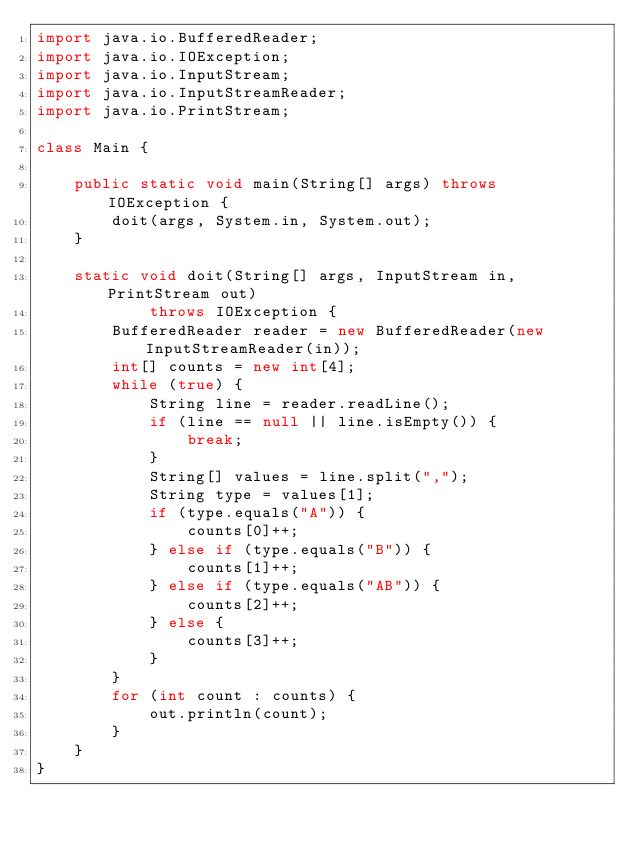Convert code to text. <code><loc_0><loc_0><loc_500><loc_500><_Java_>import java.io.BufferedReader;
import java.io.IOException;
import java.io.InputStream;
import java.io.InputStreamReader;
import java.io.PrintStream;

class Main {

    public static void main(String[] args) throws IOException {
        doit(args, System.in, System.out);
    }

    static void doit(String[] args, InputStream in, PrintStream out)
            throws IOException {
        BufferedReader reader = new BufferedReader(new InputStreamReader(in));
        int[] counts = new int[4];
        while (true) {
            String line = reader.readLine();
            if (line == null || line.isEmpty()) {
                break;
            }
            String[] values = line.split(",");
            String type = values[1];
            if (type.equals("A")) {
                counts[0]++;
            } else if (type.equals("B")) {
                counts[1]++;
            } else if (type.equals("AB")) {
                counts[2]++;
            } else {
                counts[3]++;
            }
        }
        for (int count : counts) {
            out.println(count);
        }
    }
}</code> 